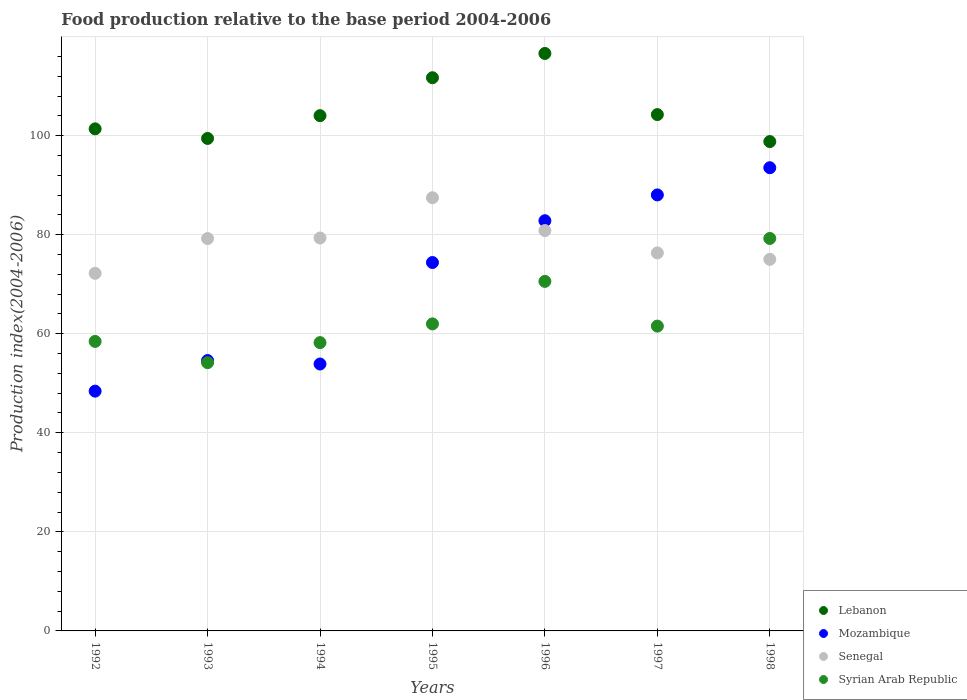Is the number of dotlines equal to the number of legend labels?
Ensure brevity in your answer.  Yes. What is the food production index in Lebanon in 1997?
Provide a succinct answer. 104.25. Across all years, what is the maximum food production index in Lebanon?
Provide a succinct answer. 116.59. Across all years, what is the minimum food production index in Mozambique?
Ensure brevity in your answer.  48.41. In which year was the food production index in Syrian Arab Republic maximum?
Your answer should be very brief. 1998. In which year was the food production index in Senegal minimum?
Offer a terse response. 1992. What is the total food production index in Lebanon in the graph?
Ensure brevity in your answer.  736.16. What is the difference between the food production index in Mozambique in 1995 and that in 1997?
Your answer should be very brief. -13.65. What is the difference between the food production index in Lebanon in 1992 and the food production index in Mozambique in 1997?
Provide a short and direct response. 13.34. What is the average food production index in Lebanon per year?
Make the answer very short. 105.17. In the year 1995, what is the difference between the food production index in Lebanon and food production index in Syrian Arab Republic?
Ensure brevity in your answer.  49.7. What is the ratio of the food production index in Mozambique in 1993 to that in 1997?
Make the answer very short. 0.62. Is the difference between the food production index in Lebanon in 1993 and 1997 greater than the difference between the food production index in Syrian Arab Republic in 1993 and 1997?
Ensure brevity in your answer.  Yes. What is the difference between the highest and the second highest food production index in Senegal?
Provide a succinct answer. 6.63. What is the difference between the highest and the lowest food production index in Senegal?
Your response must be concise. 15.26. Is the sum of the food production index in Senegal in 1992 and 1996 greater than the maximum food production index in Lebanon across all years?
Provide a short and direct response. Yes. Is it the case that in every year, the sum of the food production index in Mozambique and food production index in Senegal  is greater than the sum of food production index in Syrian Arab Republic and food production index in Lebanon?
Provide a short and direct response. Yes. Is it the case that in every year, the sum of the food production index in Syrian Arab Republic and food production index in Senegal  is greater than the food production index in Mozambique?
Offer a very short reply. Yes. Does the food production index in Mozambique monotonically increase over the years?
Make the answer very short. No. How many years are there in the graph?
Make the answer very short. 7. What is the difference between two consecutive major ticks on the Y-axis?
Your answer should be very brief. 20. Does the graph contain any zero values?
Provide a short and direct response. No. Where does the legend appear in the graph?
Your response must be concise. Bottom right. How are the legend labels stacked?
Your answer should be very brief. Vertical. What is the title of the graph?
Offer a very short reply. Food production relative to the base period 2004-2006. What is the label or title of the X-axis?
Give a very brief answer. Years. What is the label or title of the Y-axis?
Keep it short and to the point. Production index(2004-2006). What is the Production index(2004-2006) in Lebanon in 1992?
Keep it short and to the point. 101.37. What is the Production index(2004-2006) of Mozambique in 1992?
Keep it short and to the point. 48.41. What is the Production index(2004-2006) of Senegal in 1992?
Keep it short and to the point. 72.2. What is the Production index(2004-2006) of Syrian Arab Republic in 1992?
Keep it short and to the point. 58.45. What is the Production index(2004-2006) of Lebanon in 1993?
Make the answer very short. 99.43. What is the Production index(2004-2006) of Mozambique in 1993?
Make the answer very short. 54.59. What is the Production index(2004-2006) in Senegal in 1993?
Your response must be concise. 79.22. What is the Production index(2004-2006) of Syrian Arab Republic in 1993?
Offer a terse response. 54.16. What is the Production index(2004-2006) of Lebanon in 1994?
Give a very brief answer. 104.03. What is the Production index(2004-2006) in Mozambique in 1994?
Provide a short and direct response. 53.89. What is the Production index(2004-2006) of Senegal in 1994?
Give a very brief answer. 79.33. What is the Production index(2004-2006) in Syrian Arab Republic in 1994?
Provide a short and direct response. 58.21. What is the Production index(2004-2006) in Lebanon in 1995?
Offer a terse response. 111.69. What is the Production index(2004-2006) of Mozambique in 1995?
Keep it short and to the point. 74.38. What is the Production index(2004-2006) of Senegal in 1995?
Keep it short and to the point. 87.46. What is the Production index(2004-2006) of Syrian Arab Republic in 1995?
Offer a terse response. 61.99. What is the Production index(2004-2006) in Lebanon in 1996?
Provide a short and direct response. 116.59. What is the Production index(2004-2006) in Mozambique in 1996?
Provide a succinct answer. 82.82. What is the Production index(2004-2006) of Senegal in 1996?
Offer a very short reply. 80.83. What is the Production index(2004-2006) of Syrian Arab Republic in 1996?
Give a very brief answer. 70.57. What is the Production index(2004-2006) of Lebanon in 1997?
Provide a succinct answer. 104.25. What is the Production index(2004-2006) in Mozambique in 1997?
Keep it short and to the point. 88.03. What is the Production index(2004-2006) of Senegal in 1997?
Provide a succinct answer. 76.32. What is the Production index(2004-2006) in Syrian Arab Republic in 1997?
Your answer should be very brief. 61.54. What is the Production index(2004-2006) in Lebanon in 1998?
Your response must be concise. 98.8. What is the Production index(2004-2006) in Mozambique in 1998?
Provide a succinct answer. 93.52. What is the Production index(2004-2006) of Senegal in 1998?
Provide a short and direct response. 75.02. What is the Production index(2004-2006) in Syrian Arab Republic in 1998?
Ensure brevity in your answer.  79.24. Across all years, what is the maximum Production index(2004-2006) of Lebanon?
Your answer should be compact. 116.59. Across all years, what is the maximum Production index(2004-2006) in Mozambique?
Make the answer very short. 93.52. Across all years, what is the maximum Production index(2004-2006) in Senegal?
Give a very brief answer. 87.46. Across all years, what is the maximum Production index(2004-2006) of Syrian Arab Republic?
Your answer should be compact. 79.24. Across all years, what is the minimum Production index(2004-2006) of Lebanon?
Your response must be concise. 98.8. Across all years, what is the minimum Production index(2004-2006) of Mozambique?
Your response must be concise. 48.41. Across all years, what is the minimum Production index(2004-2006) in Senegal?
Your answer should be very brief. 72.2. Across all years, what is the minimum Production index(2004-2006) in Syrian Arab Republic?
Offer a very short reply. 54.16. What is the total Production index(2004-2006) in Lebanon in the graph?
Your answer should be very brief. 736.16. What is the total Production index(2004-2006) in Mozambique in the graph?
Offer a terse response. 495.64. What is the total Production index(2004-2006) of Senegal in the graph?
Provide a succinct answer. 550.38. What is the total Production index(2004-2006) in Syrian Arab Republic in the graph?
Your answer should be compact. 444.16. What is the difference between the Production index(2004-2006) in Lebanon in 1992 and that in 1993?
Offer a very short reply. 1.94. What is the difference between the Production index(2004-2006) in Mozambique in 1992 and that in 1993?
Ensure brevity in your answer.  -6.18. What is the difference between the Production index(2004-2006) in Senegal in 1992 and that in 1993?
Your response must be concise. -7.02. What is the difference between the Production index(2004-2006) of Syrian Arab Republic in 1992 and that in 1993?
Provide a short and direct response. 4.29. What is the difference between the Production index(2004-2006) in Lebanon in 1992 and that in 1994?
Give a very brief answer. -2.66. What is the difference between the Production index(2004-2006) of Mozambique in 1992 and that in 1994?
Your answer should be compact. -5.48. What is the difference between the Production index(2004-2006) in Senegal in 1992 and that in 1994?
Your answer should be compact. -7.13. What is the difference between the Production index(2004-2006) in Syrian Arab Republic in 1992 and that in 1994?
Your answer should be very brief. 0.24. What is the difference between the Production index(2004-2006) of Lebanon in 1992 and that in 1995?
Offer a very short reply. -10.32. What is the difference between the Production index(2004-2006) in Mozambique in 1992 and that in 1995?
Ensure brevity in your answer.  -25.97. What is the difference between the Production index(2004-2006) in Senegal in 1992 and that in 1995?
Make the answer very short. -15.26. What is the difference between the Production index(2004-2006) in Syrian Arab Republic in 1992 and that in 1995?
Keep it short and to the point. -3.54. What is the difference between the Production index(2004-2006) of Lebanon in 1992 and that in 1996?
Your answer should be very brief. -15.22. What is the difference between the Production index(2004-2006) in Mozambique in 1992 and that in 1996?
Make the answer very short. -34.41. What is the difference between the Production index(2004-2006) in Senegal in 1992 and that in 1996?
Provide a short and direct response. -8.63. What is the difference between the Production index(2004-2006) in Syrian Arab Republic in 1992 and that in 1996?
Give a very brief answer. -12.12. What is the difference between the Production index(2004-2006) in Lebanon in 1992 and that in 1997?
Provide a succinct answer. -2.88. What is the difference between the Production index(2004-2006) of Mozambique in 1992 and that in 1997?
Offer a terse response. -39.62. What is the difference between the Production index(2004-2006) of Senegal in 1992 and that in 1997?
Ensure brevity in your answer.  -4.12. What is the difference between the Production index(2004-2006) of Syrian Arab Republic in 1992 and that in 1997?
Provide a succinct answer. -3.09. What is the difference between the Production index(2004-2006) of Lebanon in 1992 and that in 1998?
Your answer should be very brief. 2.57. What is the difference between the Production index(2004-2006) in Mozambique in 1992 and that in 1998?
Your answer should be very brief. -45.11. What is the difference between the Production index(2004-2006) of Senegal in 1992 and that in 1998?
Your response must be concise. -2.82. What is the difference between the Production index(2004-2006) in Syrian Arab Republic in 1992 and that in 1998?
Your answer should be very brief. -20.79. What is the difference between the Production index(2004-2006) in Lebanon in 1993 and that in 1994?
Provide a succinct answer. -4.6. What is the difference between the Production index(2004-2006) in Senegal in 1993 and that in 1994?
Your response must be concise. -0.11. What is the difference between the Production index(2004-2006) in Syrian Arab Republic in 1993 and that in 1994?
Your response must be concise. -4.05. What is the difference between the Production index(2004-2006) in Lebanon in 1993 and that in 1995?
Give a very brief answer. -12.26. What is the difference between the Production index(2004-2006) in Mozambique in 1993 and that in 1995?
Provide a short and direct response. -19.79. What is the difference between the Production index(2004-2006) in Senegal in 1993 and that in 1995?
Provide a short and direct response. -8.24. What is the difference between the Production index(2004-2006) in Syrian Arab Republic in 1993 and that in 1995?
Offer a terse response. -7.83. What is the difference between the Production index(2004-2006) in Lebanon in 1993 and that in 1996?
Your answer should be compact. -17.16. What is the difference between the Production index(2004-2006) of Mozambique in 1993 and that in 1996?
Your response must be concise. -28.23. What is the difference between the Production index(2004-2006) of Senegal in 1993 and that in 1996?
Your answer should be very brief. -1.61. What is the difference between the Production index(2004-2006) in Syrian Arab Republic in 1993 and that in 1996?
Provide a succinct answer. -16.41. What is the difference between the Production index(2004-2006) of Lebanon in 1993 and that in 1997?
Your answer should be very brief. -4.82. What is the difference between the Production index(2004-2006) in Mozambique in 1993 and that in 1997?
Your answer should be very brief. -33.44. What is the difference between the Production index(2004-2006) in Syrian Arab Republic in 1993 and that in 1997?
Your answer should be compact. -7.38. What is the difference between the Production index(2004-2006) in Lebanon in 1993 and that in 1998?
Provide a short and direct response. 0.63. What is the difference between the Production index(2004-2006) in Mozambique in 1993 and that in 1998?
Give a very brief answer. -38.93. What is the difference between the Production index(2004-2006) of Syrian Arab Republic in 1993 and that in 1998?
Give a very brief answer. -25.08. What is the difference between the Production index(2004-2006) in Lebanon in 1994 and that in 1995?
Your answer should be compact. -7.66. What is the difference between the Production index(2004-2006) in Mozambique in 1994 and that in 1995?
Your response must be concise. -20.49. What is the difference between the Production index(2004-2006) of Senegal in 1994 and that in 1995?
Offer a very short reply. -8.13. What is the difference between the Production index(2004-2006) of Syrian Arab Republic in 1994 and that in 1995?
Offer a very short reply. -3.78. What is the difference between the Production index(2004-2006) of Lebanon in 1994 and that in 1996?
Offer a very short reply. -12.56. What is the difference between the Production index(2004-2006) in Mozambique in 1994 and that in 1996?
Your answer should be very brief. -28.93. What is the difference between the Production index(2004-2006) in Senegal in 1994 and that in 1996?
Your answer should be very brief. -1.5. What is the difference between the Production index(2004-2006) in Syrian Arab Republic in 1994 and that in 1996?
Give a very brief answer. -12.36. What is the difference between the Production index(2004-2006) of Lebanon in 1994 and that in 1997?
Provide a short and direct response. -0.22. What is the difference between the Production index(2004-2006) of Mozambique in 1994 and that in 1997?
Ensure brevity in your answer.  -34.14. What is the difference between the Production index(2004-2006) of Senegal in 1994 and that in 1997?
Ensure brevity in your answer.  3.01. What is the difference between the Production index(2004-2006) of Syrian Arab Republic in 1994 and that in 1997?
Make the answer very short. -3.33. What is the difference between the Production index(2004-2006) in Lebanon in 1994 and that in 1998?
Keep it short and to the point. 5.23. What is the difference between the Production index(2004-2006) of Mozambique in 1994 and that in 1998?
Make the answer very short. -39.63. What is the difference between the Production index(2004-2006) of Senegal in 1994 and that in 1998?
Your answer should be very brief. 4.31. What is the difference between the Production index(2004-2006) of Syrian Arab Republic in 1994 and that in 1998?
Give a very brief answer. -21.03. What is the difference between the Production index(2004-2006) in Mozambique in 1995 and that in 1996?
Your answer should be compact. -8.44. What is the difference between the Production index(2004-2006) in Senegal in 1995 and that in 1996?
Keep it short and to the point. 6.63. What is the difference between the Production index(2004-2006) in Syrian Arab Republic in 1995 and that in 1996?
Keep it short and to the point. -8.58. What is the difference between the Production index(2004-2006) in Lebanon in 1995 and that in 1997?
Offer a very short reply. 7.44. What is the difference between the Production index(2004-2006) of Mozambique in 1995 and that in 1997?
Make the answer very short. -13.65. What is the difference between the Production index(2004-2006) of Senegal in 1995 and that in 1997?
Keep it short and to the point. 11.14. What is the difference between the Production index(2004-2006) in Syrian Arab Republic in 1995 and that in 1997?
Give a very brief answer. 0.45. What is the difference between the Production index(2004-2006) of Lebanon in 1995 and that in 1998?
Your response must be concise. 12.89. What is the difference between the Production index(2004-2006) in Mozambique in 1995 and that in 1998?
Offer a terse response. -19.14. What is the difference between the Production index(2004-2006) of Senegal in 1995 and that in 1998?
Give a very brief answer. 12.44. What is the difference between the Production index(2004-2006) of Syrian Arab Republic in 1995 and that in 1998?
Ensure brevity in your answer.  -17.25. What is the difference between the Production index(2004-2006) of Lebanon in 1996 and that in 1997?
Make the answer very short. 12.34. What is the difference between the Production index(2004-2006) of Mozambique in 1996 and that in 1997?
Your answer should be very brief. -5.21. What is the difference between the Production index(2004-2006) of Senegal in 1996 and that in 1997?
Make the answer very short. 4.51. What is the difference between the Production index(2004-2006) of Syrian Arab Republic in 1996 and that in 1997?
Ensure brevity in your answer.  9.03. What is the difference between the Production index(2004-2006) in Lebanon in 1996 and that in 1998?
Make the answer very short. 17.79. What is the difference between the Production index(2004-2006) in Senegal in 1996 and that in 1998?
Keep it short and to the point. 5.81. What is the difference between the Production index(2004-2006) in Syrian Arab Republic in 1996 and that in 1998?
Your answer should be very brief. -8.67. What is the difference between the Production index(2004-2006) in Lebanon in 1997 and that in 1998?
Ensure brevity in your answer.  5.45. What is the difference between the Production index(2004-2006) of Mozambique in 1997 and that in 1998?
Provide a short and direct response. -5.49. What is the difference between the Production index(2004-2006) of Senegal in 1997 and that in 1998?
Provide a short and direct response. 1.3. What is the difference between the Production index(2004-2006) of Syrian Arab Republic in 1997 and that in 1998?
Your answer should be very brief. -17.7. What is the difference between the Production index(2004-2006) in Lebanon in 1992 and the Production index(2004-2006) in Mozambique in 1993?
Keep it short and to the point. 46.78. What is the difference between the Production index(2004-2006) of Lebanon in 1992 and the Production index(2004-2006) of Senegal in 1993?
Provide a succinct answer. 22.15. What is the difference between the Production index(2004-2006) of Lebanon in 1992 and the Production index(2004-2006) of Syrian Arab Republic in 1993?
Your answer should be very brief. 47.21. What is the difference between the Production index(2004-2006) in Mozambique in 1992 and the Production index(2004-2006) in Senegal in 1993?
Your response must be concise. -30.81. What is the difference between the Production index(2004-2006) in Mozambique in 1992 and the Production index(2004-2006) in Syrian Arab Republic in 1993?
Your answer should be compact. -5.75. What is the difference between the Production index(2004-2006) of Senegal in 1992 and the Production index(2004-2006) of Syrian Arab Republic in 1993?
Ensure brevity in your answer.  18.04. What is the difference between the Production index(2004-2006) of Lebanon in 1992 and the Production index(2004-2006) of Mozambique in 1994?
Offer a terse response. 47.48. What is the difference between the Production index(2004-2006) in Lebanon in 1992 and the Production index(2004-2006) in Senegal in 1994?
Make the answer very short. 22.04. What is the difference between the Production index(2004-2006) of Lebanon in 1992 and the Production index(2004-2006) of Syrian Arab Republic in 1994?
Provide a succinct answer. 43.16. What is the difference between the Production index(2004-2006) of Mozambique in 1992 and the Production index(2004-2006) of Senegal in 1994?
Your response must be concise. -30.92. What is the difference between the Production index(2004-2006) of Senegal in 1992 and the Production index(2004-2006) of Syrian Arab Republic in 1994?
Give a very brief answer. 13.99. What is the difference between the Production index(2004-2006) in Lebanon in 1992 and the Production index(2004-2006) in Mozambique in 1995?
Offer a terse response. 26.99. What is the difference between the Production index(2004-2006) of Lebanon in 1992 and the Production index(2004-2006) of Senegal in 1995?
Provide a succinct answer. 13.91. What is the difference between the Production index(2004-2006) of Lebanon in 1992 and the Production index(2004-2006) of Syrian Arab Republic in 1995?
Your answer should be compact. 39.38. What is the difference between the Production index(2004-2006) of Mozambique in 1992 and the Production index(2004-2006) of Senegal in 1995?
Keep it short and to the point. -39.05. What is the difference between the Production index(2004-2006) in Mozambique in 1992 and the Production index(2004-2006) in Syrian Arab Republic in 1995?
Your answer should be very brief. -13.58. What is the difference between the Production index(2004-2006) of Senegal in 1992 and the Production index(2004-2006) of Syrian Arab Republic in 1995?
Keep it short and to the point. 10.21. What is the difference between the Production index(2004-2006) in Lebanon in 1992 and the Production index(2004-2006) in Mozambique in 1996?
Your answer should be compact. 18.55. What is the difference between the Production index(2004-2006) of Lebanon in 1992 and the Production index(2004-2006) of Senegal in 1996?
Your answer should be compact. 20.54. What is the difference between the Production index(2004-2006) in Lebanon in 1992 and the Production index(2004-2006) in Syrian Arab Republic in 1996?
Provide a short and direct response. 30.8. What is the difference between the Production index(2004-2006) in Mozambique in 1992 and the Production index(2004-2006) in Senegal in 1996?
Provide a short and direct response. -32.42. What is the difference between the Production index(2004-2006) of Mozambique in 1992 and the Production index(2004-2006) of Syrian Arab Republic in 1996?
Keep it short and to the point. -22.16. What is the difference between the Production index(2004-2006) in Senegal in 1992 and the Production index(2004-2006) in Syrian Arab Republic in 1996?
Your response must be concise. 1.63. What is the difference between the Production index(2004-2006) in Lebanon in 1992 and the Production index(2004-2006) in Mozambique in 1997?
Keep it short and to the point. 13.34. What is the difference between the Production index(2004-2006) in Lebanon in 1992 and the Production index(2004-2006) in Senegal in 1997?
Your answer should be compact. 25.05. What is the difference between the Production index(2004-2006) of Lebanon in 1992 and the Production index(2004-2006) of Syrian Arab Republic in 1997?
Provide a succinct answer. 39.83. What is the difference between the Production index(2004-2006) in Mozambique in 1992 and the Production index(2004-2006) in Senegal in 1997?
Provide a short and direct response. -27.91. What is the difference between the Production index(2004-2006) of Mozambique in 1992 and the Production index(2004-2006) of Syrian Arab Republic in 1997?
Provide a succinct answer. -13.13. What is the difference between the Production index(2004-2006) in Senegal in 1992 and the Production index(2004-2006) in Syrian Arab Republic in 1997?
Offer a terse response. 10.66. What is the difference between the Production index(2004-2006) of Lebanon in 1992 and the Production index(2004-2006) of Mozambique in 1998?
Your answer should be very brief. 7.85. What is the difference between the Production index(2004-2006) of Lebanon in 1992 and the Production index(2004-2006) of Senegal in 1998?
Provide a short and direct response. 26.35. What is the difference between the Production index(2004-2006) of Lebanon in 1992 and the Production index(2004-2006) of Syrian Arab Republic in 1998?
Make the answer very short. 22.13. What is the difference between the Production index(2004-2006) of Mozambique in 1992 and the Production index(2004-2006) of Senegal in 1998?
Give a very brief answer. -26.61. What is the difference between the Production index(2004-2006) of Mozambique in 1992 and the Production index(2004-2006) of Syrian Arab Republic in 1998?
Your answer should be very brief. -30.83. What is the difference between the Production index(2004-2006) in Senegal in 1992 and the Production index(2004-2006) in Syrian Arab Republic in 1998?
Offer a very short reply. -7.04. What is the difference between the Production index(2004-2006) in Lebanon in 1993 and the Production index(2004-2006) in Mozambique in 1994?
Offer a very short reply. 45.54. What is the difference between the Production index(2004-2006) of Lebanon in 1993 and the Production index(2004-2006) of Senegal in 1994?
Your response must be concise. 20.1. What is the difference between the Production index(2004-2006) in Lebanon in 1993 and the Production index(2004-2006) in Syrian Arab Republic in 1994?
Make the answer very short. 41.22. What is the difference between the Production index(2004-2006) in Mozambique in 1993 and the Production index(2004-2006) in Senegal in 1994?
Ensure brevity in your answer.  -24.74. What is the difference between the Production index(2004-2006) of Mozambique in 1993 and the Production index(2004-2006) of Syrian Arab Republic in 1994?
Your answer should be compact. -3.62. What is the difference between the Production index(2004-2006) of Senegal in 1993 and the Production index(2004-2006) of Syrian Arab Republic in 1994?
Give a very brief answer. 21.01. What is the difference between the Production index(2004-2006) of Lebanon in 1993 and the Production index(2004-2006) of Mozambique in 1995?
Keep it short and to the point. 25.05. What is the difference between the Production index(2004-2006) in Lebanon in 1993 and the Production index(2004-2006) in Senegal in 1995?
Your answer should be very brief. 11.97. What is the difference between the Production index(2004-2006) in Lebanon in 1993 and the Production index(2004-2006) in Syrian Arab Republic in 1995?
Keep it short and to the point. 37.44. What is the difference between the Production index(2004-2006) of Mozambique in 1993 and the Production index(2004-2006) of Senegal in 1995?
Provide a succinct answer. -32.87. What is the difference between the Production index(2004-2006) in Senegal in 1993 and the Production index(2004-2006) in Syrian Arab Republic in 1995?
Keep it short and to the point. 17.23. What is the difference between the Production index(2004-2006) in Lebanon in 1993 and the Production index(2004-2006) in Mozambique in 1996?
Keep it short and to the point. 16.61. What is the difference between the Production index(2004-2006) of Lebanon in 1993 and the Production index(2004-2006) of Senegal in 1996?
Your answer should be very brief. 18.6. What is the difference between the Production index(2004-2006) in Lebanon in 1993 and the Production index(2004-2006) in Syrian Arab Republic in 1996?
Your response must be concise. 28.86. What is the difference between the Production index(2004-2006) of Mozambique in 1993 and the Production index(2004-2006) of Senegal in 1996?
Offer a terse response. -26.24. What is the difference between the Production index(2004-2006) of Mozambique in 1993 and the Production index(2004-2006) of Syrian Arab Republic in 1996?
Provide a succinct answer. -15.98. What is the difference between the Production index(2004-2006) in Senegal in 1993 and the Production index(2004-2006) in Syrian Arab Republic in 1996?
Provide a succinct answer. 8.65. What is the difference between the Production index(2004-2006) in Lebanon in 1993 and the Production index(2004-2006) in Mozambique in 1997?
Keep it short and to the point. 11.4. What is the difference between the Production index(2004-2006) of Lebanon in 1993 and the Production index(2004-2006) of Senegal in 1997?
Offer a very short reply. 23.11. What is the difference between the Production index(2004-2006) of Lebanon in 1993 and the Production index(2004-2006) of Syrian Arab Republic in 1997?
Provide a short and direct response. 37.89. What is the difference between the Production index(2004-2006) of Mozambique in 1993 and the Production index(2004-2006) of Senegal in 1997?
Give a very brief answer. -21.73. What is the difference between the Production index(2004-2006) of Mozambique in 1993 and the Production index(2004-2006) of Syrian Arab Republic in 1997?
Your answer should be very brief. -6.95. What is the difference between the Production index(2004-2006) of Senegal in 1993 and the Production index(2004-2006) of Syrian Arab Republic in 1997?
Your answer should be compact. 17.68. What is the difference between the Production index(2004-2006) of Lebanon in 1993 and the Production index(2004-2006) of Mozambique in 1998?
Offer a very short reply. 5.91. What is the difference between the Production index(2004-2006) of Lebanon in 1993 and the Production index(2004-2006) of Senegal in 1998?
Offer a terse response. 24.41. What is the difference between the Production index(2004-2006) of Lebanon in 1993 and the Production index(2004-2006) of Syrian Arab Republic in 1998?
Your answer should be very brief. 20.19. What is the difference between the Production index(2004-2006) of Mozambique in 1993 and the Production index(2004-2006) of Senegal in 1998?
Offer a terse response. -20.43. What is the difference between the Production index(2004-2006) in Mozambique in 1993 and the Production index(2004-2006) in Syrian Arab Republic in 1998?
Offer a terse response. -24.65. What is the difference between the Production index(2004-2006) in Senegal in 1993 and the Production index(2004-2006) in Syrian Arab Republic in 1998?
Your answer should be compact. -0.02. What is the difference between the Production index(2004-2006) of Lebanon in 1994 and the Production index(2004-2006) of Mozambique in 1995?
Offer a terse response. 29.65. What is the difference between the Production index(2004-2006) in Lebanon in 1994 and the Production index(2004-2006) in Senegal in 1995?
Give a very brief answer. 16.57. What is the difference between the Production index(2004-2006) of Lebanon in 1994 and the Production index(2004-2006) of Syrian Arab Republic in 1995?
Provide a succinct answer. 42.04. What is the difference between the Production index(2004-2006) in Mozambique in 1994 and the Production index(2004-2006) in Senegal in 1995?
Your response must be concise. -33.57. What is the difference between the Production index(2004-2006) in Mozambique in 1994 and the Production index(2004-2006) in Syrian Arab Republic in 1995?
Keep it short and to the point. -8.1. What is the difference between the Production index(2004-2006) of Senegal in 1994 and the Production index(2004-2006) of Syrian Arab Republic in 1995?
Make the answer very short. 17.34. What is the difference between the Production index(2004-2006) in Lebanon in 1994 and the Production index(2004-2006) in Mozambique in 1996?
Offer a terse response. 21.21. What is the difference between the Production index(2004-2006) in Lebanon in 1994 and the Production index(2004-2006) in Senegal in 1996?
Offer a terse response. 23.2. What is the difference between the Production index(2004-2006) in Lebanon in 1994 and the Production index(2004-2006) in Syrian Arab Republic in 1996?
Keep it short and to the point. 33.46. What is the difference between the Production index(2004-2006) in Mozambique in 1994 and the Production index(2004-2006) in Senegal in 1996?
Your answer should be compact. -26.94. What is the difference between the Production index(2004-2006) in Mozambique in 1994 and the Production index(2004-2006) in Syrian Arab Republic in 1996?
Your answer should be very brief. -16.68. What is the difference between the Production index(2004-2006) of Senegal in 1994 and the Production index(2004-2006) of Syrian Arab Republic in 1996?
Keep it short and to the point. 8.76. What is the difference between the Production index(2004-2006) in Lebanon in 1994 and the Production index(2004-2006) in Mozambique in 1997?
Provide a succinct answer. 16. What is the difference between the Production index(2004-2006) of Lebanon in 1994 and the Production index(2004-2006) of Senegal in 1997?
Your answer should be compact. 27.71. What is the difference between the Production index(2004-2006) of Lebanon in 1994 and the Production index(2004-2006) of Syrian Arab Republic in 1997?
Provide a short and direct response. 42.49. What is the difference between the Production index(2004-2006) of Mozambique in 1994 and the Production index(2004-2006) of Senegal in 1997?
Provide a short and direct response. -22.43. What is the difference between the Production index(2004-2006) in Mozambique in 1994 and the Production index(2004-2006) in Syrian Arab Republic in 1997?
Ensure brevity in your answer.  -7.65. What is the difference between the Production index(2004-2006) of Senegal in 1994 and the Production index(2004-2006) of Syrian Arab Republic in 1997?
Provide a succinct answer. 17.79. What is the difference between the Production index(2004-2006) in Lebanon in 1994 and the Production index(2004-2006) in Mozambique in 1998?
Ensure brevity in your answer.  10.51. What is the difference between the Production index(2004-2006) in Lebanon in 1994 and the Production index(2004-2006) in Senegal in 1998?
Make the answer very short. 29.01. What is the difference between the Production index(2004-2006) in Lebanon in 1994 and the Production index(2004-2006) in Syrian Arab Republic in 1998?
Provide a succinct answer. 24.79. What is the difference between the Production index(2004-2006) of Mozambique in 1994 and the Production index(2004-2006) of Senegal in 1998?
Provide a succinct answer. -21.13. What is the difference between the Production index(2004-2006) of Mozambique in 1994 and the Production index(2004-2006) of Syrian Arab Republic in 1998?
Make the answer very short. -25.35. What is the difference between the Production index(2004-2006) of Senegal in 1994 and the Production index(2004-2006) of Syrian Arab Republic in 1998?
Your answer should be very brief. 0.09. What is the difference between the Production index(2004-2006) in Lebanon in 1995 and the Production index(2004-2006) in Mozambique in 1996?
Your answer should be compact. 28.87. What is the difference between the Production index(2004-2006) of Lebanon in 1995 and the Production index(2004-2006) of Senegal in 1996?
Give a very brief answer. 30.86. What is the difference between the Production index(2004-2006) of Lebanon in 1995 and the Production index(2004-2006) of Syrian Arab Republic in 1996?
Keep it short and to the point. 41.12. What is the difference between the Production index(2004-2006) of Mozambique in 1995 and the Production index(2004-2006) of Senegal in 1996?
Make the answer very short. -6.45. What is the difference between the Production index(2004-2006) of Mozambique in 1995 and the Production index(2004-2006) of Syrian Arab Republic in 1996?
Ensure brevity in your answer.  3.81. What is the difference between the Production index(2004-2006) of Senegal in 1995 and the Production index(2004-2006) of Syrian Arab Republic in 1996?
Your answer should be very brief. 16.89. What is the difference between the Production index(2004-2006) of Lebanon in 1995 and the Production index(2004-2006) of Mozambique in 1997?
Ensure brevity in your answer.  23.66. What is the difference between the Production index(2004-2006) in Lebanon in 1995 and the Production index(2004-2006) in Senegal in 1997?
Make the answer very short. 35.37. What is the difference between the Production index(2004-2006) in Lebanon in 1995 and the Production index(2004-2006) in Syrian Arab Republic in 1997?
Offer a very short reply. 50.15. What is the difference between the Production index(2004-2006) of Mozambique in 1995 and the Production index(2004-2006) of Senegal in 1997?
Keep it short and to the point. -1.94. What is the difference between the Production index(2004-2006) of Mozambique in 1995 and the Production index(2004-2006) of Syrian Arab Republic in 1997?
Give a very brief answer. 12.84. What is the difference between the Production index(2004-2006) of Senegal in 1995 and the Production index(2004-2006) of Syrian Arab Republic in 1997?
Provide a succinct answer. 25.92. What is the difference between the Production index(2004-2006) of Lebanon in 1995 and the Production index(2004-2006) of Mozambique in 1998?
Your response must be concise. 18.17. What is the difference between the Production index(2004-2006) in Lebanon in 1995 and the Production index(2004-2006) in Senegal in 1998?
Your answer should be very brief. 36.67. What is the difference between the Production index(2004-2006) in Lebanon in 1995 and the Production index(2004-2006) in Syrian Arab Republic in 1998?
Offer a terse response. 32.45. What is the difference between the Production index(2004-2006) of Mozambique in 1995 and the Production index(2004-2006) of Senegal in 1998?
Keep it short and to the point. -0.64. What is the difference between the Production index(2004-2006) in Mozambique in 1995 and the Production index(2004-2006) in Syrian Arab Republic in 1998?
Offer a very short reply. -4.86. What is the difference between the Production index(2004-2006) of Senegal in 1995 and the Production index(2004-2006) of Syrian Arab Republic in 1998?
Ensure brevity in your answer.  8.22. What is the difference between the Production index(2004-2006) of Lebanon in 1996 and the Production index(2004-2006) of Mozambique in 1997?
Provide a succinct answer. 28.56. What is the difference between the Production index(2004-2006) in Lebanon in 1996 and the Production index(2004-2006) in Senegal in 1997?
Your answer should be very brief. 40.27. What is the difference between the Production index(2004-2006) of Lebanon in 1996 and the Production index(2004-2006) of Syrian Arab Republic in 1997?
Your response must be concise. 55.05. What is the difference between the Production index(2004-2006) of Mozambique in 1996 and the Production index(2004-2006) of Syrian Arab Republic in 1997?
Offer a terse response. 21.28. What is the difference between the Production index(2004-2006) in Senegal in 1996 and the Production index(2004-2006) in Syrian Arab Republic in 1997?
Your answer should be very brief. 19.29. What is the difference between the Production index(2004-2006) in Lebanon in 1996 and the Production index(2004-2006) in Mozambique in 1998?
Offer a terse response. 23.07. What is the difference between the Production index(2004-2006) of Lebanon in 1996 and the Production index(2004-2006) of Senegal in 1998?
Keep it short and to the point. 41.57. What is the difference between the Production index(2004-2006) in Lebanon in 1996 and the Production index(2004-2006) in Syrian Arab Republic in 1998?
Provide a succinct answer. 37.35. What is the difference between the Production index(2004-2006) of Mozambique in 1996 and the Production index(2004-2006) of Senegal in 1998?
Provide a short and direct response. 7.8. What is the difference between the Production index(2004-2006) in Mozambique in 1996 and the Production index(2004-2006) in Syrian Arab Republic in 1998?
Offer a terse response. 3.58. What is the difference between the Production index(2004-2006) of Senegal in 1996 and the Production index(2004-2006) of Syrian Arab Republic in 1998?
Ensure brevity in your answer.  1.59. What is the difference between the Production index(2004-2006) in Lebanon in 1997 and the Production index(2004-2006) in Mozambique in 1998?
Your answer should be very brief. 10.73. What is the difference between the Production index(2004-2006) of Lebanon in 1997 and the Production index(2004-2006) of Senegal in 1998?
Give a very brief answer. 29.23. What is the difference between the Production index(2004-2006) of Lebanon in 1997 and the Production index(2004-2006) of Syrian Arab Republic in 1998?
Your answer should be compact. 25.01. What is the difference between the Production index(2004-2006) of Mozambique in 1997 and the Production index(2004-2006) of Senegal in 1998?
Provide a succinct answer. 13.01. What is the difference between the Production index(2004-2006) of Mozambique in 1997 and the Production index(2004-2006) of Syrian Arab Republic in 1998?
Provide a succinct answer. 8.79. What is the difference between the Production index(2004-2006) in Senegal in 1997 and the Production index(2004-2006) in Syrian Arab Republic in 1998?
Keep it short and to the point. -2.92. What is the average Production index(2004-2006) in Lebanon per year?
Provide a short and direct response. 105.17. What is the average Production index(2004-2006) of Mozambique per year?
Keep it short and to the point. 70.81. What is the average Production index(2004-2006) in Senegal per year?
Ensure brevity in your answer.  78.63. What is the average Production index(2004-2006) of Syrian Arab Republic per year?
Offer a very short reply. 63.45. In the year 1992, what is the difference between the Production index(2004-2006) of Lebanon and Production index(2004-2006) of Mozambique?
Your response must be concise. 52.96. In the year 1992, what is the difference between the Production index(2004-2006) in Lebanon and Production index(2004-2006) in Senegal?
Keep it short and to the point. 29.17. In the year 1992, what is the difference between the Production index(2004-2006) in Lebanon and Production index(2004-2006) in Syrian Arab Republic?
Your response must be concise. 42.92. In the year 1992, what is the difference between the Production index(2004-2006) of Mozambique and Production index(2004-2006) of Senegal?
Provide a short and direct response. -23.79. In the year 1992, what is the difference between the Production index(2004-2006) in Mozambique and Production index(2004-2006) in Syrian Arab Republic?
Your response must be concise. -10.04. In the year 1992, what is the difference between the Production index(2004-2006) of Senegal and Production index(2004-2006) of Syrian Arab Republic?
Provide a short and direct response. 13.75. In the year 1993, what is the difference between the Production index(2004-2006) in Lebanon and Production index(2004-2006) in Mozambique?
Make the answer very short. 44.84. In the year 1993, what is the difference between the Production index(2004-2006) of Lebanon and Production index(2004-2006) of Senegal?
Your response must be concise. 20.21. In the year 1993, what is the difference between the Production index(2004-2006) in Lebanon and Production index(2004-2006) in Syrian Arab Republic?
Offer a very short reply. 45.27. In the year 1993, what is the difference between the Production index(2004-2006) of Mozambique and Production index(2004-2006) of Senegal?
Offer a terse response. -24.63. In the year 1993, what is the difference between the Production index(2004-2006) in Mozambique and Production index(2004-2006) in Syrian Arab Republic?
Give a very brief answer. 0.43. In the year 1993, what is the difference between the Production index(2004-2006) of Senegal and Production index(2004-2006) of Syrian Arab Republic?
Your answer should be very brief. 25.06. In the year 1994, what is the difference between the Production index(2004-2006) in Lebanon and Production index(2004-2006) in Mozambique?
Your response must be concise. 50.14. In the year 1994, what is the difference between the Production index(2004-2006) in Lebanon and Production index(2004-2006) in Senegal?
Keep it short and to the point. 24.7. In the year 1994, what is the difference between the Production index(2004-2006) in Lebanon and Production index(2004-2006) in Syrian Arab Republic?
Keep it short and to the point. 45.82. In the year 1994, what is the difference between the Production index(2004-2006) in Mozambique and Production index(2004-2006) in Senegal?
Offer a terse response. -25.44. In the year 1994, what is the difference between the Production index(2004-2006) of Mozambique and Production index(2004-2006) of Syrian Arab Republic?
Offer a terse response. -4.32. In the year 1994, what is the difference between the Production index(2004-2006) in Senegal and Production index(2004-2006) in Syrian Arab Republic?
Your answer should be very brief. 21.12. In the year 1995, what is the difference between the Production index(2004-2006) of Lebanon and Production index(2004-2006) of Mozambique?
Your answer should be very brief. 37.31. In the year 1995, what is the difference between the Production index(2004-2006) in Lebanon and Production index(2004-2006) in Senegal?
Give a very brief answer. 24.23. In the year 1995, what is the difference between the Production index(2004-2006) of Lebanon and Production index(2004-2006) of Syrian Arab Republic?
Provide a succinct answer. 49.7. In the year 1995, what is the difference between the Production index(2004-2006) in Mozambique and Production index(2004-2006) in Senegal?
Give a very brief answer. -13.08. In the year 1995, what is the difference between the Production index(2004-2006) of Mozambique and Production index(2004-2006) of Syrian Arab Republic?
Offer a very short reply. 12.39. In the year 1995, what is the difference between the Production index(2004-2006) of Senegal and Production index(2004-2006) of Syrian Arab Republic?
Provide a succinct answer. 25.47. In the year 1996, what is the difference between the Production index(2004-2006) of Lebanon and Production index(2004-2006) of Mozambique?
Provide a short and direct response. 33.77. In the year 1996, what is the difference between the Production index(2004-2006) of Lebanon and Production index(2004-2006) of Senegal?
Offer a terse response. 35.76. In the year 1996, what is the difference between the Production index(2004-2006) in Lebanon and Production index(2004-2006) in Syrian Arab Republic?
Ensure brevity in your answer.  46.02. In the year 1996, what is the difference between the Production index(2004-2006) in Mozambique and Production index(2004-2006) in Senegal?
Provide a short and direct response. 1.99. In the year 1996, what is the difference between the Production index(2004-2006) of Mozambique and Production index(2004-2006) of Syrian Arab Republic?
Make the answer very short. 12.25. In the year 1996, what is the difference between the Production index(2004-2006) in Senegal and Production index(2004-2006) in Syrian Arab Republic?
Your answer should be compact. 10.26. In the year 1997, what is the difference between the Production index(2004-2006) in Lebanon and Production index(2004-2006) in Mozambique?
Your answer should be very brief. 16.22. In the year 1997, what is the difference between the Production index(2004-2006) of Lebanon and Production index(2004-2006) of Senegal?
Offer a very short reply. 27.93. In the year 1997, what is the difference between the Production index(2004-2006) in Lebanon and Production index(2004-2006) in Syrian Arab Republic?
Provide a short and direct response. 42.71. In the year 1997, what is the difference between the Production index(2004-2006) of Mozambique and Production index(2004-2006) of Senegal?
Ensure brevity in your answer.  11.71. In the year 1997, what is the difference between the Production index(2004-2006) of Mozambique and Production index(2004-2006) of Syrian Arab Republic?
Provide a short and direct response. 26.49. In the year 1997, what is the difference between the Production index(2004-2006) in Senegal and Production index(2004-2006) in Syrian Arab Republic?
Your answer should be very brief. 14.78. In the year 1998, what is the difference between the Production index(2004-2006) in Lebanon and Production index(2004-2006) in Mozambique?
Give a very brief answer. 5.28. In the year 1998, what is the difference between the Production index(2004-2006) of Lebanon and Production index(2004-2006) of Senegal?
Your answer should be compact. 23.78. In the year 1998, what is the difference between the Production index(2004-2006) in Lebanon and Production index(2004-2006) in Syrian Arab Republic?
Your answer should be compact. 19.56. In the year 1998, what is the difference between the Production index(2004-2006) in Mozambique and Production index(2004-2006) in Syrian Arab Republic?
Provide a succinct answer. 14.28. In the year 1998, what is the difference between the Production index(2004-2006) of Senegal and Production index(2004-2006) of Syrian Arab Republic?
Your answer should be compact. -4.22. What is the ratio of the Production index(2004-2006) of Lebanon in 1992 to that in 1993?
Offer a very short reply. 1.02. What is the ratio of the Production index(2004-2006) of Mozambique in 1992 to that in 1993?
Give a very brief answer. 0.89. What is the ratio of the Production index(2004-2006) of Senegal in 1992 to that in 1993?
Give a very brief answer. 0.91. What is the ratio of the Production index(2004-2006) in Syrian Arab Republic in 1992 to that in 1993?
Offer a terse response. 1.08. What is the ratio of the Production index(2004-2006) in Lebanon in 1992 to that in 1994?
Offer a terse response. 0.97. What is the ratio of the Production index(2004-2006) in Mozambique in 1992 to that in 1994?
Ensure brevity in your answer.  0.9. What is the ratio of the Production index(2004-2006) in Senegal in 1992 to that in 1994?
Your answer should be very brief. 0.91. What is the ratio of the Production index(2004-2006) in Syrian Arab Republic in 1992 to that in 1994?
Keep it short and to the point. 1. What is the ratio of the Production index(2004-2006) in Lebanon in 1992 to that in 1995?
Make the answer very short. 0.91. What is the ratio of the Production index(2004-2006) in Mozambique in 1992 to that in 1995?
Your answer should be compact. 0.65. What is the ratio of the Production index(2004-2006) of Senegal in 1992 to that in 1995?
Your answer should be compact. 0.83. What is the ratio of the Production index(2004-2006) of Syrian Arab Republic in 1992 to that in 1995?
Your response must be concise. 0.94. What is the ratio of the Production index(2004-2006) of Lebanon in 1992 to that in 1996?
Provide a short and direct response. 0.87. What is the ratio of the Production index(2004-2006) in Mozambique in 1992 to that in 1996?
Offer a terse response. 0.58. What is the ratio of the Production index(2004-2006) of Senegal in 1992 to that in 1996?
Give a very brief answer. 0.89. What is the ratio of the Production index(2004-2006) in Syrian Arab Republic in 1992 to that in 1996?
Ensure brevity in your answer.  0.83. What is the ratio of the Production index(2004-2006) of Lebanon in 1992 to that in 1997?
Your answer should be very brief. 0.97. What is the ratio of the Production index(2004-2006) in Mozambique in 1992 to that in 1997?
Your answer should be very brief. 0.55. What is the ratio of the Production index(2004-2006) of Senegal in 1992 to that in 1997?
Make the answer very short. 0.95. What is the ratio of the Production index(2004-2006) of Syrian Arab Republic in 1992 to that in 1997?
Your answer should be very brief. 0.95. What is the ratio of the Production index(2004-2006) in Mozambique in 1992 to that in 1998?
Offer a very short reply. 0.52. What is the ratio of the Production index(2004-2006) of Senegal in 1992 to that in 1998?
Provide a short and direct response. 0.96. What is the ratio of the Production index(2004-2006) in Syrian Arab Republic in 1992 to that in 1998?
Offer a very short reply. 0.74. What is the ratio of the Production index(2004-2006) in Lebanon in 1993 to that in 1994?
Ensure brevity in your answer.  0.96. What is the ratio of the Production index(2004-2006) in Mozambique in 1993 to that in 1994?
Keep it short and to the point. 1.01. What is the ratio of the Production index(2004-2006) in Senegal in 1993 to that in 1994?
Provide a short and direct response. 1. What is the ratio of the Production index(2004-2006) in Syrian Arab Republic in 1993 to that in 1994?
Keep it short and to the point. 0.93. What is the ratio of the Production index(2004-2006) in Lebanon in 1993 to that in 1995?
Provide a succinct answer. 0.89. What is the ratio of the Production index(2004-2006) of Mozambique in 1993 to that in 1995?
Your response must be concise. 0.73. What is the ratio of the Production index(2004-2006) of Senegal in 1993 to that in 1995?
Provide a succinct answer. 0.91. What is the ratio of the Production index(2004-2006) in Syrian Arab Republic in 1993 to that in 1995?
Provide a succinct answer. 0.87. What is the ratio of the Production index(2004-2006) in Lebanon in 1993 to that in 1996?
Your answer should be compact. 0.85. What is the ratio of the Production index(2004-2006) of Mozambique in 1993 to that in 1996?
Give a very brief answer. 0.66. What is the ratio of the Production index(2004-2006) in Senegal in 1993 to that in 1996?
Offer a very short reply. 0.98. What is the ratio of the Production index(2004-2006) of Syrian Arab Republic in 1993 to that in 1996?
Make the answer very short. 0.77. What is the ratio of the Production index(2004-2006) of Lebanon in 1993 to that in 1997?
Offer a very short reply. 0.95. What is the ratio of the Production index(2004-2006) in Mozambique in 1993 to that in 1997?
Offer a terse response. 0.62. What is the ratio of the Production index(2004-2006) of Senegal in 1993 to that in 1997?
Your response must be concise. 1.04. What is the ratio of the Production index(2004-2006) of Syrian Arab Republic in 1993 to that in 1997?
Offer a terse response. 0.88. What is the ratio of the Production index(2004-2006) of Lebanon in 1993 to that in 1998?
Ensure brevity in your answer.  1.01. What is the ratio of the Production index(2004-2006) of Mozambique in 1993 to that in 1998?
Your answer should be compact. 0.58. What is the ratio of the Production index(2004-2006) of Senegal in 1993 to that in 1998?
Give a very brief answer. 1.06. What is the ratio of the Production index(2004-2006) in Syrian Arab Republic in 1993 to that in 1998?
Keep it short and to the point. 0.68. What is the ratio of the Production index(2004-2006) in Lebanon in 1994 to that in 1995?
Your answer should be very brief. 0.93. What is the ratio of the Production index(2004-2006) of Mozambique in 1994 to that in 1995?
Ensure brevity in your answer.  0.72. What is the ratio of the Production index(2004-2006) in Senegal in 1994 to that in 1995?
Ensure brevity in your answer.  0.91. What is the ratio of the Production index(2004-2006) in Syrian Arab Republic in 1994 to that in 1995?
Provide a succinct answer. 0.94. What is the ratio of the Production index(2004-2006) in Lebanon in 1994 to that in 1996?
Offer a very short reply. 0.89. What is the ratio of the Production index(2004-2006) in Mozambique in 1994 to that in 1996?
Make the answer very short. 0.65. What is the ratio of the Production index(2004-2006) in Senegal in 1994 to that in 1996?
Give a very brief answer. 0.98. What is the ratio of the Production index(2004-2006) of Syrian Arab Republic in 1994 to that in 1996?
Offer a terse response. 0.82. What is the ratio of the Production index(2004-2006) in Mozambique in 1994 to that in 1997?
Offer a very short reply. 0.61. What is the ratio of the Production index(2004-2006) of Senegal in 1994 to that in 1997?
Provide a succinct answer. 1.04. What is the ratio of the Production index(2004-2006) of Syrian Arab Republic in 1994 to that in 1997?
Provide a succinct answer. 0.95. What is the ratio of the Production index(2004-2006) in Lebanon in 1994 to that in 1998?
Provide a succinct answer. 1.05. What is the ratio of the Production index(2004-2006) in Mozambique in 1994 to that in 1998?
Ensure brevity in your answer.  0.58. What is the ratio of the Production index(2004-2006) in Senegal in 1994 to that in 1998?
Provide a short and direct response. 1.06. What is the ratio of the Production index(2004-2006) in Syrian Arab Republic in 1994 to that in 1998?
Provide a succinct answer. 0.73. What is the ratio of the Production index(2004-2006) of Lebanon in 1995 to that in 1996?
Your answer should be compact. 0.96. What is the ratio of the Production index(2004-2006) of Mozambique in 1995 to that in 1996?
Make the answer very short. 0.9. What is the ratio of the Production index(2004-2006) of Senegal in 1995 to that in 1996?
Ensure brevity in your answer.  1.08. What is the ratio of the Production index(2004-2006) of Syrian Arab Republic in 1995 to that in 1996?
Offer a very short reply. 0.88. What is the ratio of the Production index(2004-2006) in Lebanon in 1995 to that in 1997?
Give a very brief answer. 1.07. What is the ratio of the Production index(2004-2006) of Mozambique in 1995 to that in 1997?
Provide a succinct answer. 0.84. What is the ratio of the Production index(2004-2006) of Senegal in 1995 to that in 1997?
Your response must be concise. 1.15. What is the ratio of the Production index(2004-2006) of Syrian Arab Republic in 1995 to that in 1997?
Your answer should be compact. 1.01. What is the ratio of the Production index(2004-2006) in Lebanon in 1995 to that in 1998?
Your answer should be compact. 1.13. What is the ratio of the Production index(2004-2006) in Mozambique in 1995 to that in 1998?
Keep it short and to the point. 0.8. What is the ratio of the Production index(2004-2006) of Senegal in 1995 to that in 1998?
Keep it short and to the point. 1.17. What is the ratio of the Production index(2004-2006) of Syrian Arab Republic in 1995 to that in 1998?
Offer a very short reply. 0.78. What is the ratio of the Production index(2004-2006) in Lebanon in 1996 to that in 1997?
Your answer should be compact. 1.12. What is the ratio of the Production index(2004-2006) of Mozambique in 1996 to that in 1997?
Provide a succinct answer. 0.94. What is the ratio of the Production index(2004-2006) in Senegal in 1996 to that in 1997?
Provide a succinct answer. 1.06. What is the ratio of the Production index(2004-2006) of Syrian Arab Republic in 1996 to that in 1997?
Make the answer very short. 1.15. What is the ratio of the Production index(2004-2006) in Lebanon in 1996 to that in 1998?
Provide a succinct answer. 1.18. What is the ratio of the Production index(2004-2006) in Mozambique in 1996 to that in 1998?
Keep it short and to the point. 0.89. What is the ratio of the Production index(2004-2006) of Senegal in 1996 to that in 1998?
Your answer should be very brief. 1.08. What is the ratio of the Production index(2004-2006) in Syrian Arab Republic in 1996 to that in 1998?
Your answer should be compact. 0.89. What is the ratio of the Production index(2004-2006) in Lebanon in 1997 to that in 1998?
Give a very brief answer. 1.06. What is the ratio of the Production index(2004-2006) in Mozambique in 1997 to that in 1998?
Provide a succinct answer. 0.94. What is the ratio of the Production index(2004-2006) in Senegal in 1997 to that in 1998?
Your response must be concise. 1.02. What is the ratio of the Production index(2004-2006) in Syrian Arab Republic in 1997 to that in 1998?
Provide a short and direct response. 0.78. What is the difference between the highest and the second highest Production index(2004-2006) in Mozambique?
Offer a terse response. 5.49. What is the difference between the highest and the second highest Production index(2004-2006) of Senegal?
Your answer should be very brief. 6.63. What is the difference between the highest and the second highest Production index(2004-2006) of Syrian Arab Republic?
Give a very brief answer. 8.67. What is the difference between the highest and the lowest Production index(2004-2006) in Lebanon?
Offer a very short reply. 17.79. What is the difference between the highest and the lowest Production index(2004-2006) of Mozambique?
Ensure brevity in your answer.  45.11. What is the difference between the highest and the lowest Production index(2004-2006) of Senegal?
Offer a very short reply. 15.26. What is the difference between the highest and the lowest Production index(2004-2006) of Syrian Arab Republic?
Provide a short and direct response. 25.08. 